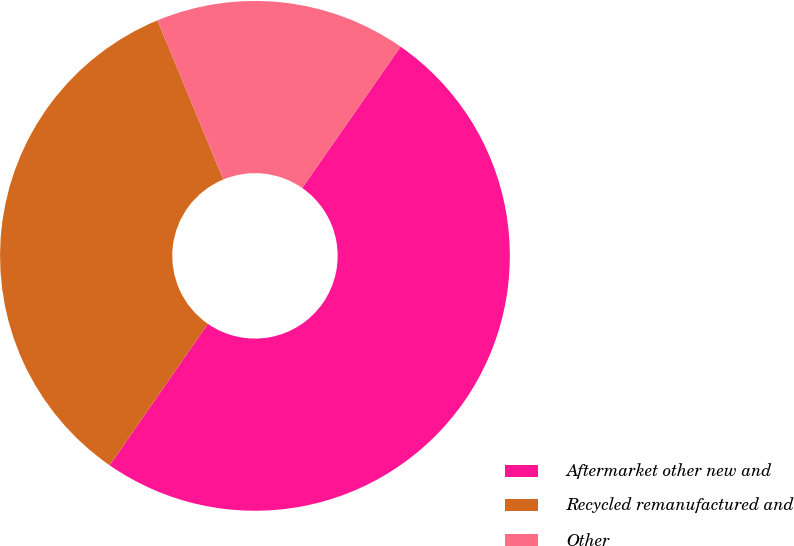Convert chart to OTSL. <chart><loc_0><loc_0><loc_500><loc_500><pie_chart><fcel>Aftermarket other new and<fcel>Recycled remanufactured and<fcel>Other<nl><fcel>49.97%<fcel>34.1%<fcel>15.93%<nl></chart> 